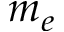<formula> <loc_0><loc_0><loc_500><loc_500>m _ { e }</formula> 